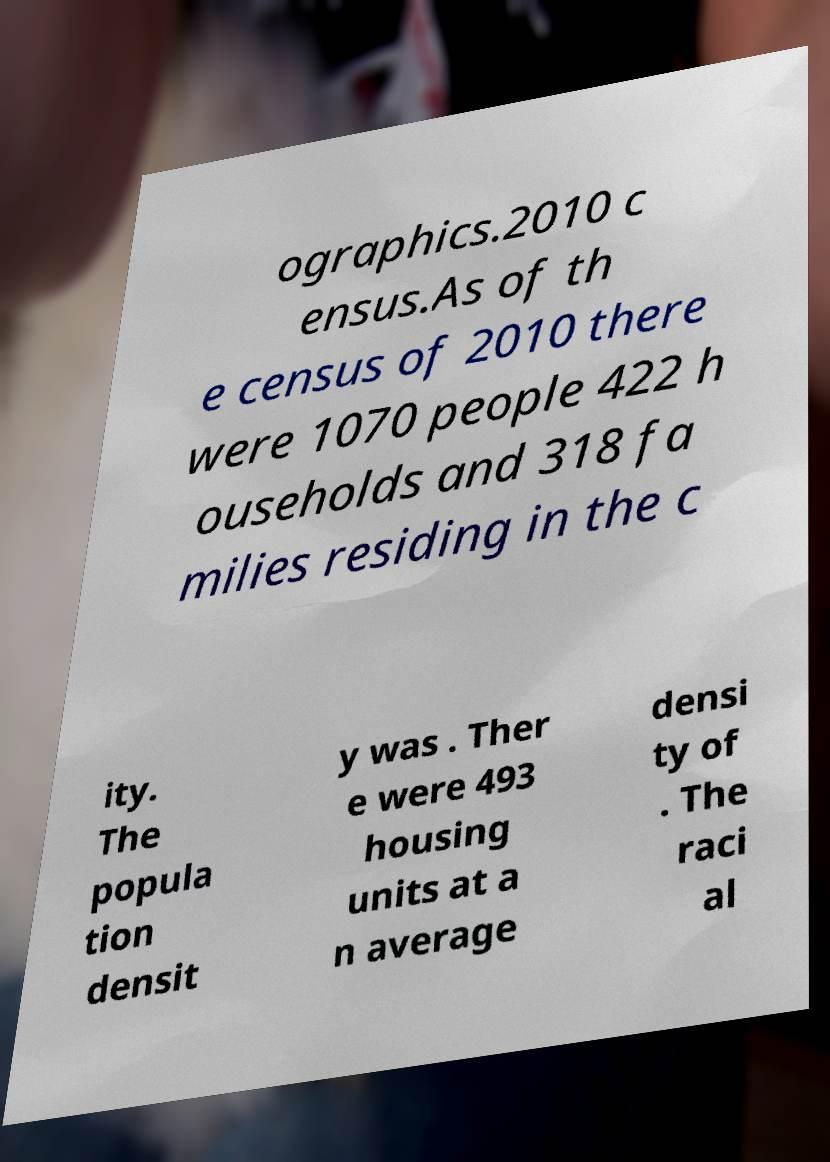For documentation purposes, I need the text within this image transcribed. Could you provide that? ographics.2010 c ensus.As of th e census of 2010 there were 1070 people 422 h ouseholds and 318 fa milies residing in the c ity. The popula tion densit y was . Ther e were 493 housing units at a n average densi ty of . The raci al 